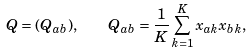Convert formula to latex. <formula><loc_0><loc_0><loc_500><loc_500>Q = ( Q _ { a b } ) , \quad Q _ { a b } = \frac { 1 } { K } \sum _ { k = 1 } ^ { K } x _ { a k } x _ { b k } ,</formula> 